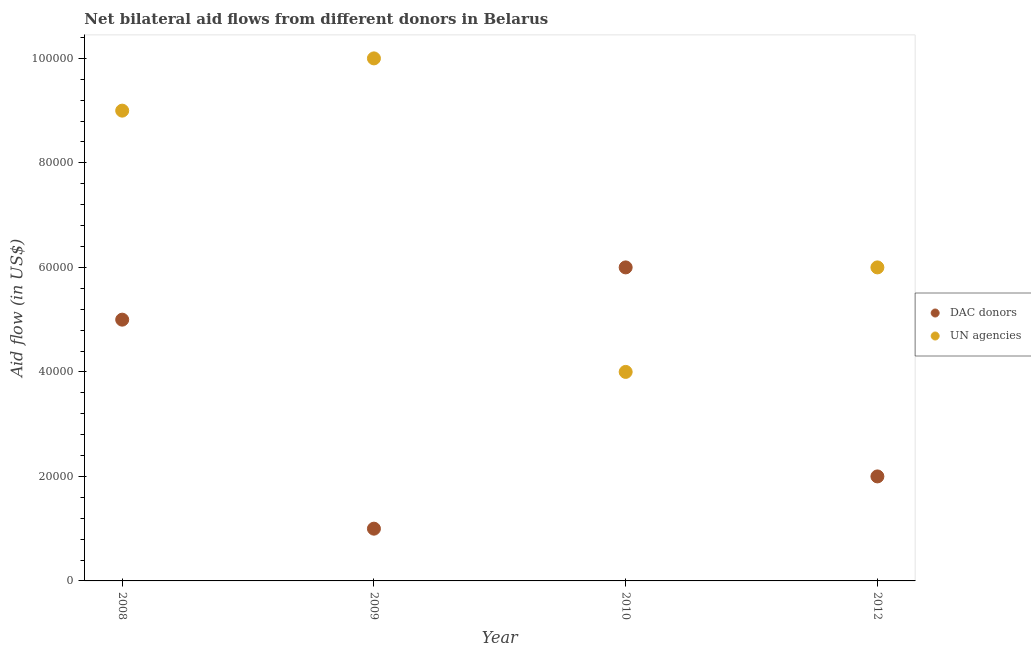Is the number of dotlines equal to the number of legend labels?
Provide a short and direct response. Yes. What is the aid flow from dac donors in 2012?
Keep it short and to the point. 2.00e+04. Across all years, what is the maximum aid flow from dac donors?
Keep it short and to the point. 6.00e+04. Across all years, what is the minimum aid flow from un agencies?
Your answer should be very brief. 4.00e+04. In which year was the aid flow from dac donors maximum?
Offer a terse response. 2010. What is the total aid flow from dac donors in the graph?
Your response must be concise. 1.40e+05. What is the difference between the aid flow from dac donors in 2009 and that in 2010?
Make the answer very short. -5.00e+04. What is the difference between the aid flow from dac donors in 2012 and the aid flow from un agencies in 2008?
Your answer should be very brief. -7.00e+04. What is the average aid flow from dac donors per year?
Provide a succinct answer. 3.50e+04. In the year 2010, what is the difference between the aid flow from un agencies and aid flow from dac donors?
Keep it short and to the point. -2.00e+04. In how many years, is the aid flow from dac donors greater than 88000 US$?
Your answer should be very brief. 0. What is the ratio of the aid flow from dac donors in 2009 to that in 2010?
Provide a short and direct response. 0.17. Is the difference between the aid flow from un agencies in 2008 and 2012 greater than the difference between the aid flow from dac donors in 2008 and 2012?
Ensure brevity in your answer.  No. What is the difference between the highest and the lowest aid flow from dac donors?
Your answer should be very brief. 5.00e+04. In how many years, is the aid flow from dac donors greater than the average aid flow from dac donors taken over all years?
Your response must be concise. 2. Does the aid flow from un agencies monotonically increase over the years?
Offer a very short reply. No. Is the aid flow from dac donors strictly greater than the aid flow from un agencies over the years?
Offer a very short reply. No. Is the aid flow from un agencies strictly less than the aid flow from dac donors over the years?
Make the answer very short. No. How many dotlines are there?
Your answer should be very brief. 2. What is the difference between two consecutive major ticks on the Y-axis?
Offer a very short reply. 2.00e+04. Are the values on the major ticks of Y-axis written in scientific E-notation?
Give a very brief answer. No. How are the legend labels stacked?
Ensure brevity in your answer.  Vertical. What is the title of the graph?
Your answer should be compact. Net bilateral aid flows from different donors in Belarus. Does "Domestic Liabilities" appear as one of the legend labels in the graph?
Provide a succinct answer. No. What is the label or title of the X-axis?
Offer a very short reply. Year. What is the label or title of the Y-axis?
Your answer should be compact. Aid flow (in US$). What is the Aid flow (in US$) of UN agencies in 2008?
Provide a short and direct response. 9.00e+04. What is the Aid flow (in US$) of DAC donors in 2010?
Your response must be concise. 6.00e+04. What is the Aid flow (in US$) of UN agencies in 2010?
Offer a terse response. 4.00e+04. What is the Aid flow (in US$) of UN agencies in 2012?
Your answer should be very brief. 6.00e+04. Across all years, what is the maximum Aid flow (in US$) in UN agencies?
Offer a very short reply. 1.00e+05. Across all years, what is the minimum Aid flow (in US$) of DAC donors?
Provide a succinct answer. 10000. What is the total Aid flow (in US$) in DAC donors in the graph?
Give a very brief answer. 1.40e+05. What is the total Aid flow (in US$) in UN agencies in the graph?
Give a very brief answer. 2.90e+05. What is the difference between the Aid flow (in US$) of DAC donors in 2008 and that in 2009?
Offer a terse response. 4.00e+04. What is the difference between the Aid flow (in US$) in DAC donors in 2008 and that in 2010?
Your response must be concise. -10000. What is the difference between the Aid flow (in US$) in UN agencies in 2008 and that in 2010?
Provide a short and direct response. 5.00e+04. What is the difference between the Aid flow (in US$) of DAC donors in 2008 and that in 2012?
Make the answer very short. 3.00e+04. What is the difference between the Aid flow (in US$) in UN agencies in 2008 and that in 2012?
Provide a succinct answer. 3.00e+04. What is the difference between the Aid flow (in US$) in UN agencies in 2009 and that in 2012?
Offer a terse response. 4.00e+04. What is the difference between the Aid flow (in US$) of UN agencies in 2010 and that in 2012?
Your answer should be compact. -2.00e+04. What is the difference between the Aid flow (in US$) in DAC donors in 2008 and the Aid flow (in US$) in UN agencies in 2009?
Give a very brief answer. -5.00e+04. What is the difference between the Aid flow (in US$) of DAC donors in 2009 and the Aid flow (in US$) of UN agencies in 2010?
Keep it short and to the point. -3.00e+04. What is the average Aid flow (in US$) in DAC donors per year?
Make the answer very short. 3.50e+04. What is the average Aid flow (in US$) in UN agencies per year?
Offer a very short reply. 7.25e+04. In the year 2008, what is the difference between the Aid flow (in US$) of DAC donors and Aid flow (in US$) of UN agencies?
Provide a short and direct response. -4.00e+04. What is the ratio of the Aid flow (in US$) of DAC donors in 2008 to that in 2009?
Ensure brevity in your answer.  5. What is the ratio of the Aid flow (in US$) in UN agencies in 2008 to that in 2010?
Make the answer very short. 2.25. What is the ratio of the Aid flow (in US$) in UN agencies in 2008 to that in 2012?
Offer a terse response. 1.5. What is the ratio of the Aid flow (in US$) in UN agencies in 2009 to that in 2010?
Provide a short and direct response. 2.5. What is the ratio of the Aid flow (in US$) in DAC donors in 2009 to that in 2012?
Your response must be concise. 0.5. What is the ratio of the Aid flow (in US$) of UN agencies in 2010 to that in 2012?
Provide a succinct answer. 0.67. What is the difference between the highest and the second highest Aid flow (in US$) in DAC donors?
Provide a short and direct response. 10000. What is the difference between the highest and the second highest Aid flow (in US$) in UN agencies?
Make the answer very short. 10000. 